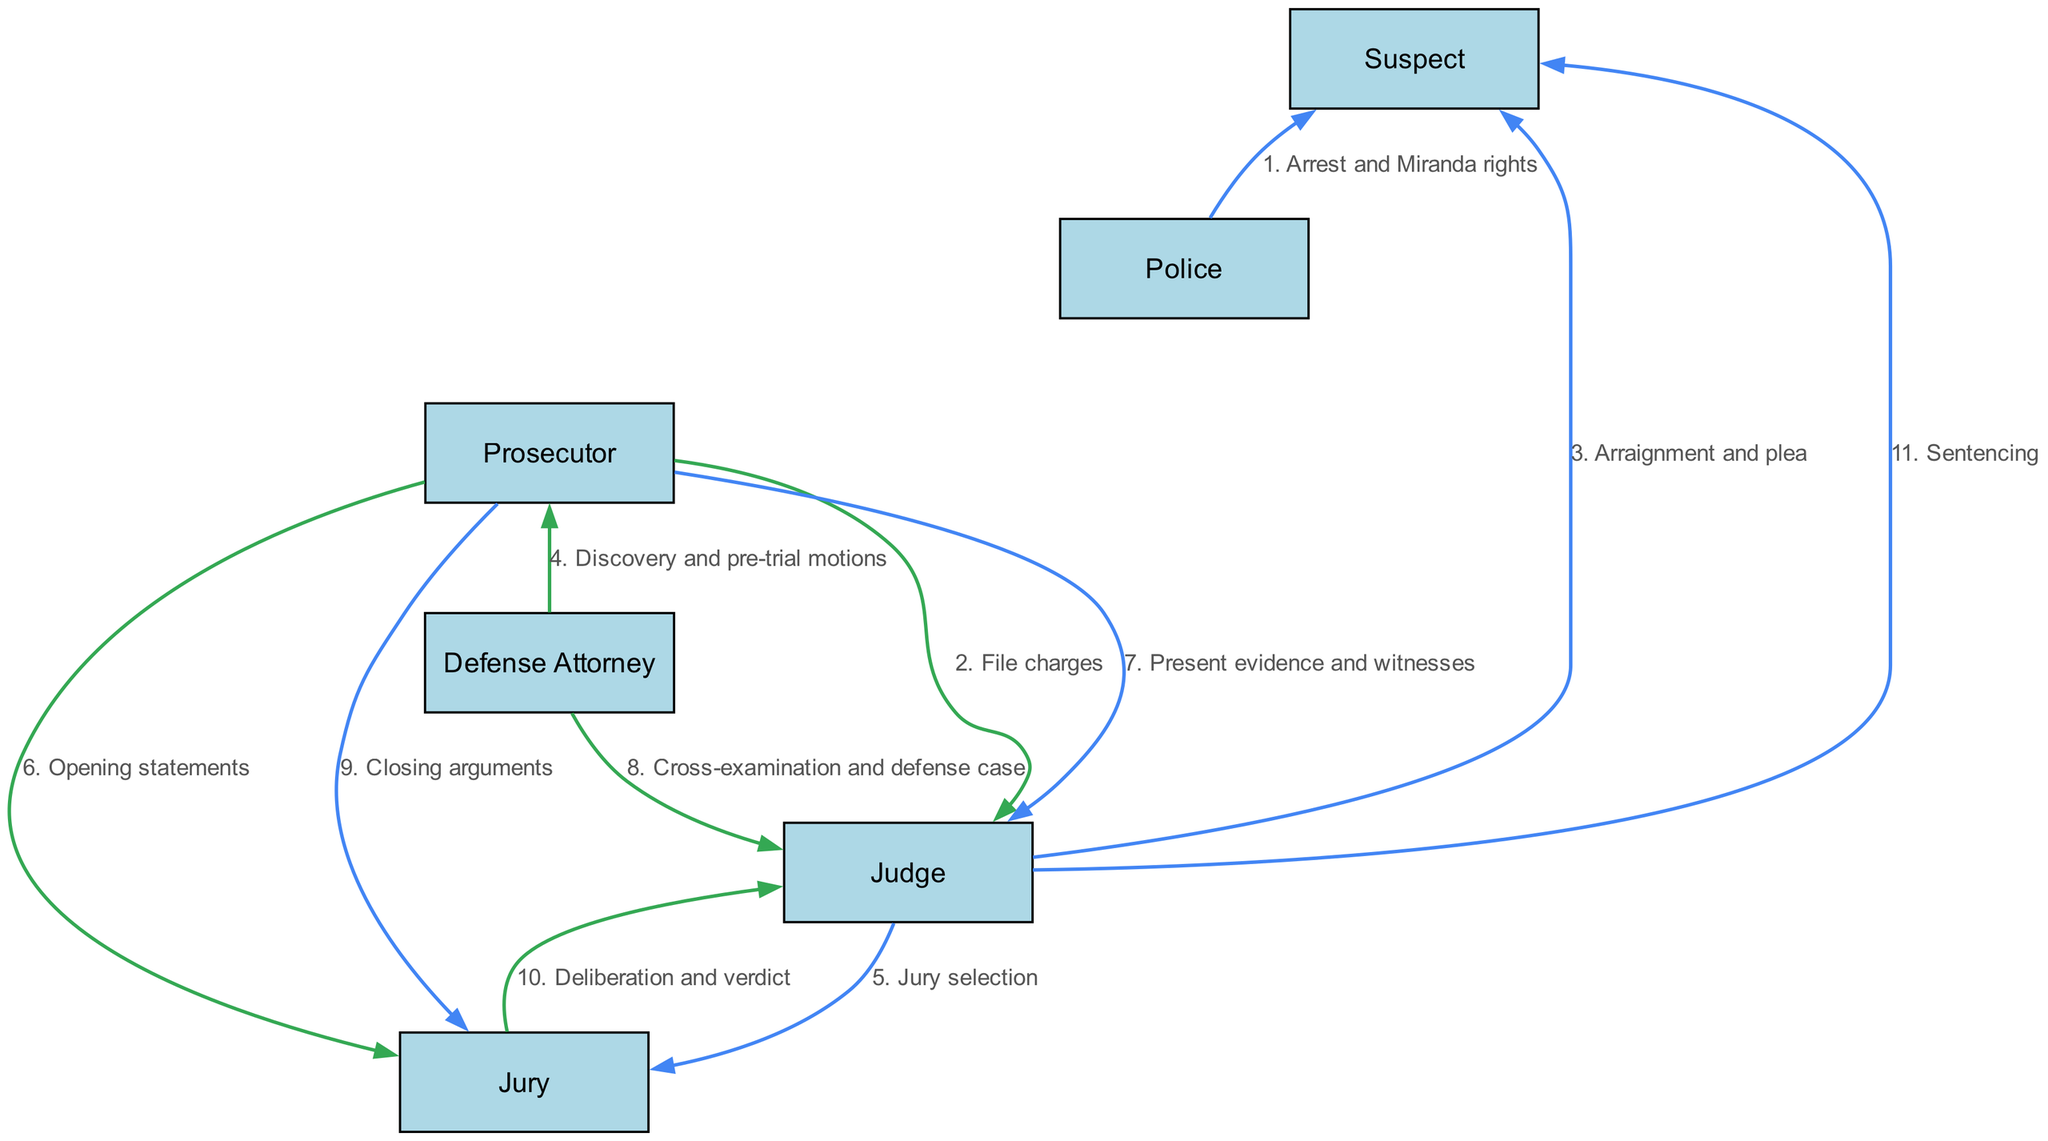What is the first action in the sequence? The first action is "Arrest and Miranda rights," which comes from the Police to the Suspect. It is the initial step in the diagram.
Answer: Arrest and Miranda rights How many participants are involved in the trial sequence? The diagram lists six participants: Suspect, Police, Prosecutor, Defense Attorney, Judge, and Jury. Therefore, the total count is six.
Answer: Six Who presents evidence and witnesses? The action of "Present evidence and witnesses" is carried out by the Prosecutor to the Judge. This can be seen as a specific action in the sequence.
Answer: Prosecutor At which stage does the Jury deliver their decision? The Jury delivers their decision during the "Deliberation and verdict" action, which is directed to the Judge. This follows their previous actions in the sequence.
Answer: Deliberation and verdict Which participant is involved in sentencing? The Judge is responsible for the "Sentencing" action, which is the final action directed toward the Suspect in the sequence.
Answer: Judge What action follows the jury selection? Following the "Jury selection" action, the next action is "Opening statements," which involves the Prosecutor addressing the Jury. This shows a clear flow from one action to the next.
Answer: Opening statements How many actions are initiated by the Prosecutor? The Prosecutor initiates three actions in the sequence: "File charges," "Opening statements," and "Present evidence and witnesses." Thus, the total count of Prosecutor actions is three.
Answer: Three What is the relationship between the Defense Attorney and the Prosecutor during pre-trial? The relationship is based on the action "Discovery and pre-trial motions," where the Defense Attorney communicates with the Prosecutor, indicating a cooperative yet adversarial interaction.
Answer: Cooperation What is the last action noted in the sequence? The last action mentioned in the sequence is "Sentencing," which is executed by the Judge directed toward the Suspect, marking the conclusion of the trial process.
Answer: Sentencing 